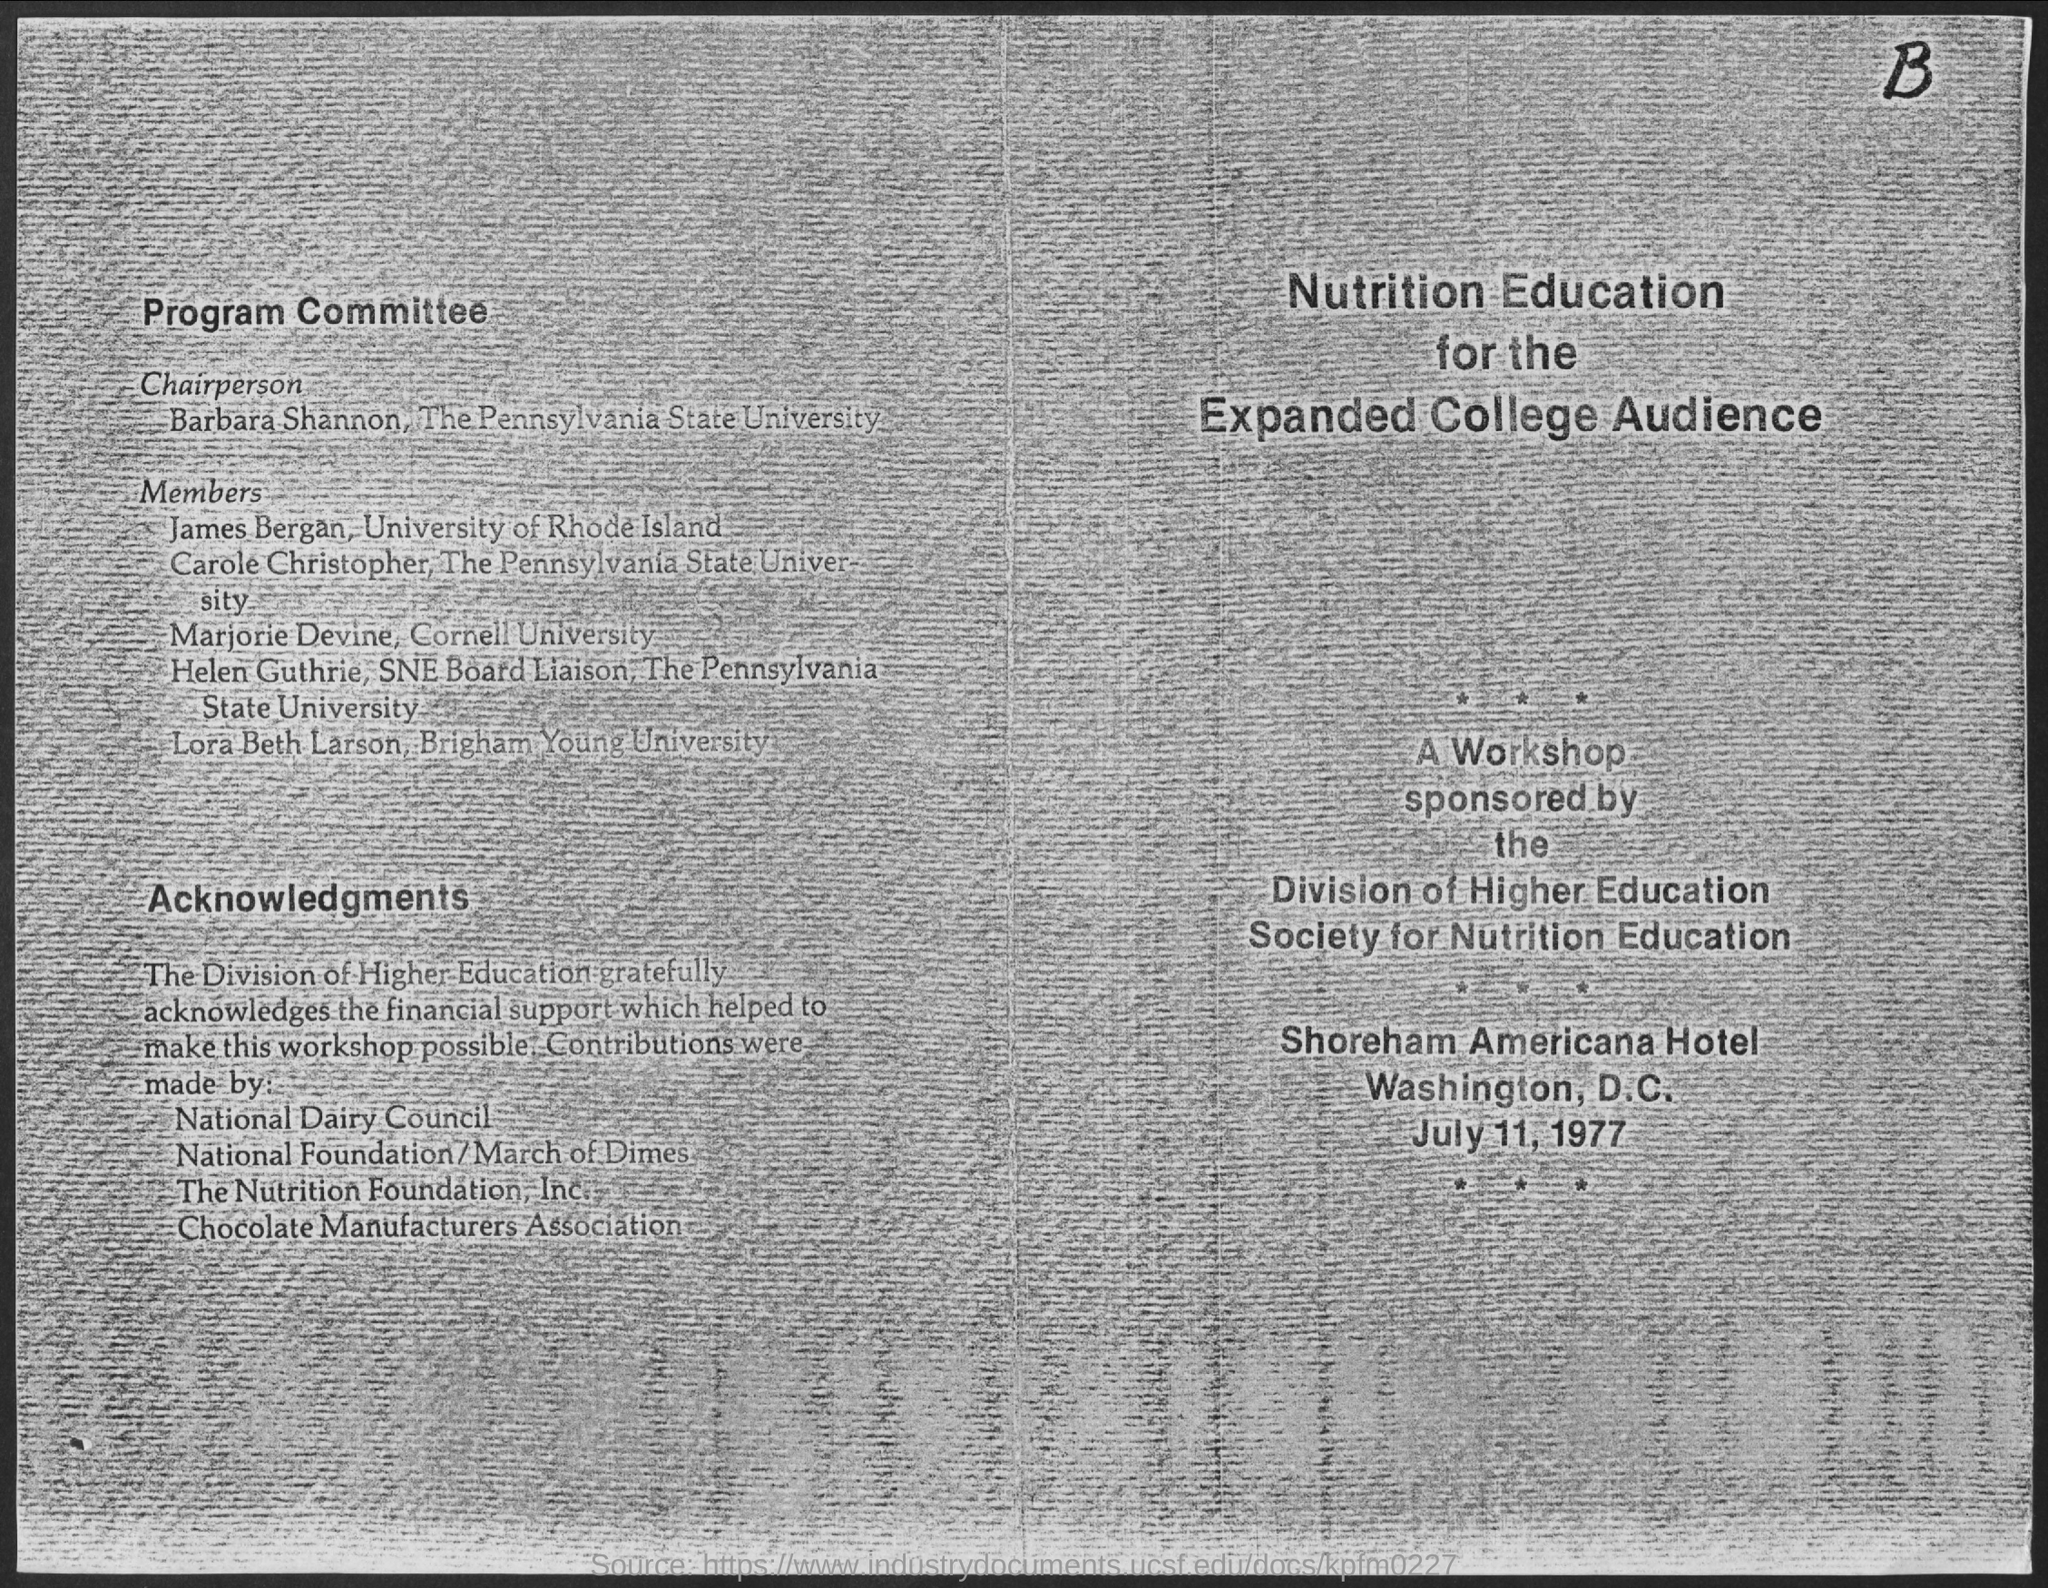List a handful of essential elements in this visual. The Chairperson of the Program Committee is Barbara Shannon. The workshop will be held on July 11, 1977. Lora Beth Larson is a student at Brigham Young University. The main title of this document is 'Nutrition Education for the Expanded College Audience.' 